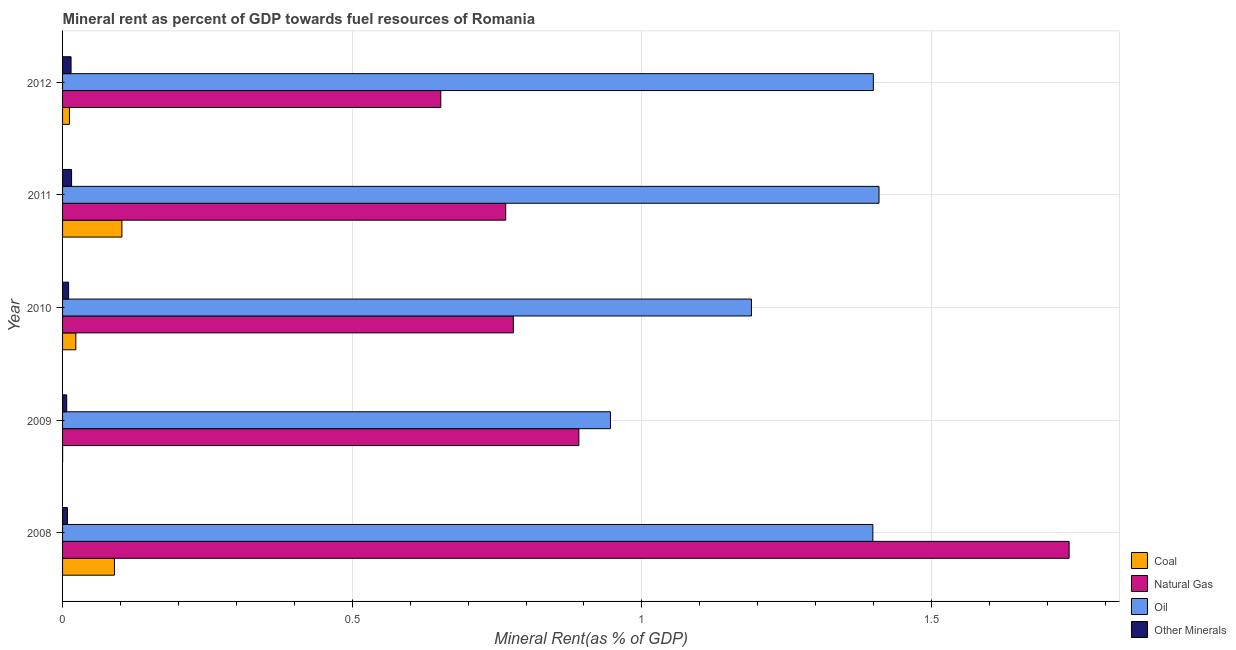Are the number of bars on each tick of the Y-axis equal?
Your response must be concise. Yes. How many bars are there on the 4th tick from the top?
Your answer should be very brief. 4. How many bars are there on the 3rd tick from the bottom?
Your response must be concise. 4. What is the  rent of other minerals in 2010?
Ensure brevity in your answer.  0.01. Across all years, what is the maximum  rent of other minerals?
Provide a succinct answer. 0.02. Across all years, what is the minimum coal rent?
Your answer should be very brief. 9.91154234092374e-5. In which year was the coal rent maximum?
Your answer should be compact. 2011. What is the total oil rent in the graph?
Keep it short and to the point. 6.34. What is the difference between the coal rent in 2011 and that in 2012?
Keep it short and to the point. 0.09. What is the difference between the natural gas rent in 2009 and the coal rent in 2012?
Your answer should be very brief. 0.88. What is the average coal rent per year?
Your answer should be very brief. 0.04. In the year 2008, what is the difference between the  rent of other minerals and oil rent?
Ensure brevity in your answer.  -1.39. In how many years, is the  rent of other minerals greater than 1.6 %?
Ensure brevity in your answer.  0. What is the ratio of the coal rent in 2010 to that in 2011?
Your answer should be very brief. 0.22. Is the coal rent in 2008 less than that in 2011?
Give a very brief answer. Yes. What does the 1st bar from the top in 2011 represents?
Make the answer very short. Other Minerals. What does the 2nd bar from the bottom in 2008 represents?
Your answer should be very brief. Natural Gas. Is it the case that in every year, the sum of the coal rent and natural gas rent is greater than the oil rent?
Your answer should be very brief. No. How many years are there in the graph?
Offer a very short reply. 5. What is the difference between two consecutive major ticks on the X-axis?
Your answer should be compact. 0.5. How are the legend labels stacked?
Your response must be concise. Vertical. What is the title of the graph?
Your answer should be compact. Mineral rent as percent of GDP towards fuel resources of Romania. What is the label or title of the X-axis?
Keep it short and to the point. Mineral Rent(as % of GDP). What is the Mineral Rent(as % of GDP) in Coal in 2008?
Offer a terse response. 0.09. What is the Mineral Rent(as % of GDP) in Natural Gas in 2008?
Provide a succinct answer. 1.74. What is the Mineral Rent(as % of GDP) in Oil in 2008?
Your answer should be very brief. 1.4. What is the Mineral Rent(as % of GDP) in Other Minerals in 2008?
Make the answer very short. 0.01. What is the Mineral Rent(as % of GDP) in Coal in 2009?
Make the answer very short. 9.91154234092374e-5. What is the Mineral Rent(as % of GDP) of Natural Gas in 2009?
Offer a terse response. 0.89. What is the Mineral Rent(as % of GDP) of Oil in 2009?
Make the answer very short. 0.95. What is the Mineral Rent(as % of GDP) in Other Minerals in 2009?
Provide a succinct answer. 0.01. What is the Mineral Rent(as % of GDP) in Coal in 2010?
Your answer should be very brief. 0.02. What is the Mineral Rent(as % of GDP) in Natural Gas in 2010?
Keep it short and to the point. 0.78. What is the Mineral Rent(as % of GDP) in Oil in 2010?
Offer a terse response. 1.19. What is the Mineral Rent(as % of GDP) in Other Minerals in 2010?
Provide a short and direct response. 0.01. What is the Mineral Rent(as % of GDP) in Coal in 2011?
Offer a very short reply. 0.1. What is the Mineral Rent(as % of GDP) in Natural Gas in 2011?
Offer a terse response. 0.76. What is the Mineral Rent(as % of GDP) in Oil in 2011?
Your response must be concise. 1.41. What is the Mineral Rent(as % of GDP) of Other Minerals in 2011?
Ensure brevity in your answer.  0.02. What is the Mineral Rent(as % of GDP) of Coal in 2012?
Provide a succinct answer. 0.01. What is the Mineral Rent(as % of GDP) of Natural Gas in 2012?
Your answer should be very brief. 0.65. What is the Mineral Rent(as % of GDP) of Oil in 2012?
Ensure brevity in your answer.  1.4. What is the Mineral Rent(as % of GDP) of Other Minerals in 2012?
Your answer should be very brief. 0.01. Across all years, what is the maximum Mineral Rent(as % of GDP) of Coal?
Your answer should be very brief. 0.1. Across all years, what is the maximum Mineral Rent(as % of GDP) of Natural Gas?
Your answer should be compact. 1.74. Across all years, what is the maximum Mineral Rent(as % of GDP) in Oil?
Offer a very short reply. 1.41. Across all years, what is the maximum Mineral Rent(as % of GDP) in Other Minerals?
Ensure brevity in your answer.  0.02. Across all years, what is the minimum Mineral Rent(as % of GDP) in Coal?
Keep it short and to the point. 9.91154234092374e-5. Across all years, what is the minimum Mineral Rent(as % of GDP) in Natural Gas?
Your response must be concise. 0.65. Across all years, what is the minimum Mineral Rent(as % of GDP) of Oil?
Keep it short and to the point. 0.95. Across all years, what is the minimum Mineral Rent(as % of GDP) of Other Minerals?
Provide a succinct answer. 0.01. What is the total Mineral Rent(as % of GDP) in Coal in the graph?
Your answer should be compact. 0.23. What is the total Mineral Rent(as % of GDP) in Natural Gas in the graph?
Keep it short and to the point. 4.82. What is the total Mineral Rent(as % of GDP) in Oil in the graph?
Your response must be concise. 6.34. What is the total Mineral Rent(as % of GDP) of Other Minerals in the graph?
Provide a short and direct response. 0.06. What is the difference between the Mineral Rent(as % of GDP) of Coal in 2008 and that in 2009?
Make the answer very short. 0.09. What is the difference between the Mineral Rent(as % of GDP) of Natural Gas in 2008 and that in 2009?
Your response must be concise. 0.85. What is the difference between the Mineral Rent(as % of GDP) of Oil in 2008 and that in 2009?
Keep it short and to the point. 0.45. What is the difference between the Mineral Rent(as % of GDP) of Other Minerals in 2008 and that in 2009?
Ensure brevity in your answer.  0. What is the difference between the Mineral Rent(as % of GDP) in Coal in 2008 and that in 2010?
Keep it short and to the point. 0.07. What is the difference between the Mineral Rent(as % of GDP) in Natural Gas in 2008 and that in 2010?
Give a very brief answer. 0.96. What is the difference between the Mineral Rent(as % of GDP) of Oil in 2008 and that in 2010?
Your response must be concise. 0.21. What is the difference between the Mineral Rent(as % of GDP) in Other Minerals in 2008 and that in 2010?
Make the answer very short. -0. What is the difference between the Mineral Rent(as % of GDP) in Coal in 2008 and that in 2011?
Keep it short and to the point. -0.01. What is the difference between the Mineral Rent(as % of GDP) of Natural Gas in 2008 and that in 2011?
Provide a succinct answer. 0.97. What is the difference between the Mineral Rent(as % of GDP) of Oil in 2008 and that in 2011?
Make the answer very short. -0.01. What is the difference between the Mineral Rent(as % of GDP) of Other Minerals in 2008 and that in 2011?
Make the answer very short. -0.01. What is the difference between the Mineral Rent(as % of GDP) in Coal in 2008 and that in 2012?
Ensure brevity in your answer.  0.08. What is the difference between the Mineral Rent(as % of GDP) of Natural Gas in 2008 and that in 2012?
Provide a succinct answer. 1.08. What is the difference between the Mineral Rent(as % of GDP) of Oil in 2008 and that in 2012?
Make the answer very short. -0. What is the difference between the Mineral Rent(as % of GDP) of Other Minerals in 2008 and that in 2012?
Ensure brevity in your answer.  -0.01. What is the difference between the Mineral Rent(as % of GDP) of Coal in 2009 and that in 2010?
Your answer should be very brief. -0.02. What is the difference between the Mineral Rent(as % of GDP) in Natural Gas in 2009 and that in 2010?
Give a very brief answer. 0.11. What is the difference between the Mineral Rent(as % of GDP) in Oil in 2009 and that in 2010?
Keep it short and to the point. -0.24. What is the difference between the Mineral Rent(as % of GDP) in Other Minerals in 2009 and that in 2010?
Offer a very short reply. -0. What is the difference between the Mineral Rent(as % of GDP) of Coal in 2009 and that in 2011?
Your answer should be compact. -0.1. What is the difference between the Mineral Rent(as % of GDP) of Natural Gas in 2009 and that in 2011?
Your response must be concise. 0.13. What is the difference between the Mineral Rent(as % of GDP) in Oil in 2009 and that in 2011?
Offer a terse response. -0.46. What is the difference between the Mineral Rent(as % of GDP) in Other Minerals in 2009 and that in 2011?
Give a very brief answer. -0.01. What is the difference between the Mineral Rent(as % of GDP) in Coal in 2009 and that in 2012?
Give a very brief answer. -0.01. What is the difference between the Mineral Rent(as % of GDP) in Natural Gas in 2009 and that in 2012?
Provide a succinct answer. 0.24. What is the difference between the Mineral Rent(as % of GDP) in Oil in 2009 and that in 2012?
Ensure brevity in your answer.  -0.45. What is the difference between the Mineral Rent(as % of GDP) in Other Minerals in 2009 and that in 2012?
Your answer should be compact. -0.01. What is the difference between the Mineral Rent(as % of GDP) of Coal in 2010 and that in 2011?
Provide a succinct answer. -0.08. What is the difference between the Mineral Rent(as % of GDP) in Natural Gas in 2010 and that in 2011?
Ensure brevity in your answer.  0.01. What is the difference between the Mineral Rent(as % of GDP) of Oil in 2010 and that in 2011?
Offer a terse response. -0.22. What is the difference between the Mineral Rent(as % of GDP) of Other Minerals in 2010 and that in 2011?
Ensure brevity in your answer.  -0.01. What is the difference between the Mineral Rent(as % of GDP) in Coal in 2010 and that in 2012?
Your answer should be very brief. 0.01. What is the difference between the Mineral Rent(as % of GDP) of Natural Gas in 2010 and that in 2012?
Ensure brevity in your answer.  0.13. What is the difference between the Mineral Rent(as % of GDP) of Oil in 2010 and that in 2012?
Your response must be concise. -0.21. What is the difference between the Mineral Rent(as % of GDP) of Other Minerals in 2010 and that in 2012?
Your response must be concise. -0. What is the difference between the Mineral Rent(as % of GDP) of Coal in 2011 and that in 2012?
Make the answer very short. 0.09. What is the difference between the Mineral Rent(as % of GDP) in Natural Gas in 2011 and that in 2012?
Give a very brief answer. 0.11. What is the difference between the Mineral Rent(as % of GDP) of Oil in 2011 and that in 2012?
Provide a short and direct response. 0.01. What is the difference between the Mineral Rent(as % of GDP) of Other Minerals in 2011 and that in 2012?
Your response must be concise. 0. What is the difference between the Mineral Rent(as % of GDP) in Coal in 2008 and the Mineral Rent(as % of GDP) in Natural Gas in 2009?
Offer a terse response. -0.8. What is the difference between the Mineral Rent(as % of GDP) in Coal in 2008 and the Mineral Rent(as % of GDP) in Oil in 2009?
Give a very brief answer. -0.86. What is the difference between the Mineral Rent(as % of GDP) of Coal in 2008 and the Mineral Rent(as % of GDP) of Other Minerals in 2009?
Keep it short and to the point. 0.08. What is the difference between the Mineral Rent(as % of GDP) in Natural Gas in 2008 and the Mineral Rent(as % of GDP) in Oil in 2009?
Your answer should be compact. 0.79. What is the difference between the Mineral Rent(as % of GDP) of Natural Gas in 2008 and the Mineral Rent(as % of GDP) of Other Minerals in 2009?
Your answer should be very brief. 1.73. What is the difference between the Mineral Rent(as % of GDP) in Oil in 2008 and the Mineral Rent(as % of GDP) in Other Minerals in 2009?
Keep it short and to the point. 1.39. What is the difference between the Mineral Rent(as % of GDP) in Coal in 2008 and the Mineral Rent(as % of GDP) in Natural Gas in 2010?
Your answer should be very brief. -0.69. What is the difference between the Mineral Rent(as % of GDP) in Coal in 2008 and the Mineral Rent(as % of GDP) in Oil in 2010?
Your response must be concise. -1.1. What is the difference between the Mineral Rent(as % of GDP) in Coal in 2008 and the Mineral Rent(as % of GDP) in Other Minerals in 2010?
Your answer should be compact. 0.08. What is the difference between the Mineral Rent(as % of GDP) in Natural Gas in 2008 and the Mineral Rent(as % of GDP) in Oil in 2010?
Your answer should be compact. 0.55. What is the difference between the Mineral Rent(as % of GDP) in Natural Gas in 2008 and the Mineral Rent(as % of GDP) in Other Minerals in 2010?
Provide a succinct answer. 1.73. What is the difference between the Mineral Rent(as % of GDP) in Oil in 2008 and the Mineral Rent(as % of GDP) in Other Minerals in 2010?
Provide a succinct answer. 1.39. What is the difference between the Mineral Rent(as % of GDP) in Coal in 2008 and the Mineral Rent(as % of GDP) in Natural Gas in 2011?
Keep it short and to the point. -0.68. What is the difference between the Mineral Rent(as % of GDP) in Coal in 2008 and the Mineral Rent(as % of GDP) in Oil in 2011?
Your answer should be compact. -1.32. What is the difference between the Mineral Rent(as % of GDP) in Coal in 2008 and the Mineral Rent(as % of GDP) in Other Minerals in 2011?
Provide a succinct answer. 0.07. What is the difference between the Mineral Rent(as % of GDP) of Natural Gas in 2008 and the Mineral Rent(as % of GDP) of Oil in 2011?
Offer a very short reply. 0.33. What is the difference between the Mineral Rent(as % of GDP) in Natural Gas in 2008 and the Mineral Rent(as % of GDP) in Other Minerals in 2011?
Give a very brief answer. 1.72. What is the difference between the Mineral Rent(as % of GDP) in Oil in 2008 and the Mineral Rent(as % of GDP) in Other Minerals in 2011?
Offer a very short reply. 1.38. What is the difference between the Mineral Rent(as % of GDP) of Coal in 2008 and the Mineral Rent(as % of GDP) of Natural Gas in 2012?
Provide a short and direct response. -0.56. What is the difference between the Mineral Rent(as % of GDP) of Coal in 2008 and the Mineral Rent(as % of GDP) of Oil in 2012?
Your response must be concise. -1.31. What is the difference between the Mineral Rent(as % of GDP) in Coal in 2008 and the Mineral Rent(as % of GDP) in Other Minerals in 2012?
Your answer should be very brief. 0.07. What is the difference between the Mineral Rent(as % of GDP) in Natural Gas in 2008 and the Mineral Rent(as % of GDP) in Oil in 2012?
Give a very brief answer. 0.34. What is the difference between the Mineral Rent(as % of GDP) in Natural Gas in 2008 and the Mineral Rent(as % of GDP) in Other Minerals in 2012?
Provide a succinct answer. 1.72. What is the difference between the Mineral Rent(as % of GDP) of Oil in 2008 and the Mineral Rent(as % of GDP) of Other Minerals in 2012?
Provide a short and direct response. 1.38. What is the difference between the Mineral Rent(as % of GDP) in Coal in 2009 and the Mineral Rent(as % of GDP) in Natural Gas in 2010?
Keep it short and to the point. -0.78. What is the difference between the Mineral Rent(as % of GDP) in Coal in 2009 and the Mineral Rent(as % of GDP) in Oil in 2010?
Your answer should be very brief. -1.19. What is the difference between the Mineral Rent(as % of GDP) of Coal in 2009 and the Mineral Rent(as % of GDP) of Other Minerals in 2010?
Make the answer very short. -0.01. What is the difference between the Mineral Rent(as % of GDP) of Natural Gas in 2009 and the Mineral Rent(as % of GDP) of Oil in 2010?
Give a very brief answer. -0.3. What is the difference between the Mineral Rent(as % of GDP) in Natural Gas in 2009 and the Mineral Rent(as % of GDP) in Other Minerals in 2010?
Offer a terse response. 0.88. What is the difference between the Mineral Rent(as % of GDP) in Oil in 2009 and the Mineral Rent(as % of GDP) in Other Minerals in 2010?
Give a very brief answer. 0.94. What is the difference between the Mineral Rent(as % of GDP) in Coal in 2009 and the Mineral Rent(as % of GDP) in Natural Gas in 2011?
Offer a terse response. -0.76. What is the difference between the Mineral Rent(as % of GDP) of Coal in 2009 and the Mineral Rent(as % of GDP) of Oil in 2011?
Your answer should be very brief. -1.41. What is the difference between the Mineral Rent(as % of GDP) in Coal in 2009 and the Mineral Rent(as % of GDP) in Other Minerals in 2011?
Your response must be concise. -0.02. What is the difference between the Mineral Rent(as % of GDP) in Natural Gas in 2009 and the Mineral Rent(as % of GDP) in Oil in 2011?
Your answer should be very brief. -0.52. What is the difference between the Mineral Rent(as % of GDP) of Natural Gas in 2009 and the Mineral Rent(as % of GDP) of Other Minerals in 2011?
Your response must be concise. 0.88. What is the difference between the Mineral Rent(as % of GDP) of Oil in 2009 and the Mineral Rent(as % of GDP) of Other Minerals in 2011?
Your answer should be very brief. 0.93. What is the difference between the Mineral Rent(as % of GDP) in Coal in 2009 and the Mineral Rent(as % of GDP) in Natural Gas in 2012?
Offer a very short reply. -0.65. What is the difference between the Mineral Rent(as % of GDP) in Coal in 2009 and the Mineral Rent(as % of GDP) in Oil in 2012?
Offer a terse response. -1.4. What is the difference between the Mineral Rent(as % of GDP) of Coal in 2009 and the Mineral Rent(as % of GDP) of Other Minerals in 2012?
Offer a very short reply. -0.01. What is the difference between the Mineral Rent(as % of GDP) of Natural Gas in 2009 and the Mineral Rent(as % of GDP) of Oil in 2012?
Your answer should be compact. -0.51. What is the difference between the Mineral Rent(as % of GDP) of Natural Gas in 2009 and the Mineral Rent(as % of GDP) of Other Minerals in 2012?
Offer a very short reply. 0.88. What is the difference between the Mineral Rent(as % of GDP) of Coal in 2010 and the Mineral Rent(as % of GDP) of Natural Gas in 2011?
Give a very brief answer. -0.74. What is the difference between the Mineral Rent(as % of GDP) of Coal in 2010 and the Mineral Rent(as % of GDP) of Oil in 2011?
Provide a succinct answer. -1.39. What is the difference between the Mineral Rent(as % of GDP) in Coal in 2010 and the Mineral Rent(as % of GDP) in Other Minerals in 2011?
Offer a terse response. 0.01. What is the difference between the Mineral Rent(as % of GDP) in Natural Gas in 2010 and the Mineral Rent(as % of GDP) in Oil in 2011?
Your answer should be compact. -0.63. What is the difference between the Mineral Rent(as % of GDP) of Natural Gas in 2010 and the Mineral Rent(as % of GDP) of Other Minerals in 2011?
Make the answer very short. 0.76. What is the difference between the Mineral Rent(as % of GDP) in Oil in 2010 and the Mineral Rent(as % of GDP) in Other Minerals in 2011?
Provide a succinct answer. 1.17. What is the difference between the Mineral Rent(as % of GDP) of Coal in 2010 and the Mineral Rent(as % of GDP) of Natural Gas in 2012?
Keep it short and to the point. -0.63. What is the difference between the Mineral Rent(as % of GDP) of Coal in 2010 and the Mineral Rent(as % of GDP) of Oil in 2012?
Your answer should be compact. -1.38. What is the difference between the Mineral Rent(as % of GDP) of Coal in 2010 and the Mineral Rent(as % of GDP) of Other Minerals in 2012?
Make the answer very short. 0.01. What is the difference between the Mineral Rent(as % of GDP) in Natural Gas in 2010 and the Mineral Rent(as % of GDP) in Oil in 2012?
Give a very brief answer. -0.62. What is the difference between the Mineral Rent(as % of GDP) in Natural Gas in 2010 and the Mineral Rent(as % of GDP) in Other Minerals in 2012?
Offer a very short reply. 0.76. What is the difference between the Mineral Rent(as % of GDP) of Oil in 2010 and the Mineral Rent(as % of GDP) of Other Minerals in 2012?
Provide a short and direct response. 1.17. What is the difference between the Mineral Rent(as % of GDP) in Coal in 2011 and the Mineral Rent(as % of GDP) in Natural Gas in 2012?
Give a very brief answer. -0.55. What is the difference between the Mineral Rent(as % of GDP) in Coal in 2011 and the Mineral Rent(as % of GDP) in Oil in 2012?
Make the answer very short. -1.3. What is the difference between the Mineral Rent(as % of GDP) of Coal in 2011 and the Mineral Rent(as % of GDP) of Other Minerals in 2012?
Your answer should be compact. 0.09. What is the difference between the Mineral Rent(as % of GDP) of Natural Gas in 2011 and the Mineral Rent(as % of GDP) of Oil in 2012?
Your answer should be compact. -0.63. What is the difference between the Mineral Rent(as % of GDP) of Natural Gas in 2011 and the Mineral Rent(as % of GDP) of Other Minerals in 2012?
Give a very brief answer. 0.75. What is the difference between the Mineral Rent(as % of GDP) in Oil in 2011 and the Mineral Rent(as % of GDP) in Other Minerals in 2012?
Keep it short and to the point. 1.39. What is the average Mineral Rent(as % of GDP) of Coal per year?
Your answer should be compact. 0.05. What is the average Mineral Rent(as % of GDP) of Natural Gas per year?
Keep it short and to the point. 0.96. What is the average Mineral Rent(as % of GDP) of Oil per year?
Offer a terse response. 1.27. What is the average Mineral Rent(as % of GDP) of Other Minerals per year?
Provide a short and direct response. 0.01. In the year 2008, what is the difference between the Mineral Rent(as % of GDP) of Coal and Mineral Rent(as % of GDP) of Natural Gas?
Provide a succinct answer. -1.65. In the year 2008, what is the difference between the Mineral Rent(as % of GDP) in Coal and Mineral Rent(as % of GDP) in Oil?
Ensure brevity in your answer.  -1.31. In the year 2008, what is the difference between the Mineral Rent(as % of GDP) of Coal and Mineral Rent(as % of GDP) of Other Minerals?
Provide a short and direct response. 0.08. In the year 2008, what is the difference between the Mineral Rent(as % of GDP) of Natural Gas and Mineral Rent(as % of GDP) of Oil?
Ensure brevity in your answer.  0.34. In the year 2008, what is the difference between the Mineral Rent(as % of GDP) of Natural Gas and Mineral Rent(as % of GDP) of Other Minerals?
Provide a succinct answer. 1.73. In the year 2008, what is the difference between the Mineral Rent(as % of GDP) of Oil and Mineral Rent(as % of GDP) of Other Minerals?
Make the answer very short. 1.39. In the year 2009, what is the difference between the Mineral Rent(as % of GDP) of Coal and Mineral Rent(as % of GDP) of Natural Gas?
Give a very brief answer. -0.89. In the year 2009, what is the difference between the Mineral Rent(as % of GDP) of Coal and Mineral Rent(as % of GDP) of Oil?
Provide a succinct answer. -0.95. In the year 2009, what is the difference between the Mineral Rent(as % of GDP) in Coal and Mineral Rent(as % of GDP) in Other Minerals?
Ensure brevity in your answer.  -0.01. In the year 2009, what is the difference between the Mineral Rent(as % of GDP) in Natural Gas and Mineral Rent(as % of GDP) in Oil?
Provide a succinct answer. -0.05. In the year 2009, what is the difference between the Mineral Rent(as % of GDP) in Natural Gas and Mineral Rent(as % of GDP) in Other Minerals?
Your response must be concise. 0.88. In the year 2009, what is the difference between the Mineral Rent(as % of GDP) of Oil and Mineral Rent(as % of GDP) of Other Minerals?
Ensure brevity in your answer.  0.94. In the year 2010, what is the difference between the Mineral Rent(as % of GDP) of Coal and Mineral Rent(as % of GDP) of Natural Gas?
Your response must be concise. -0.76. In the year 2010, what is the difference between the Mineral Rent(as % of GDP) in Coal and Mineral Rent(as % of GDP) in Oil?
Give a very brief answer. -1.17. In the year 2010, what is the difference between the Mineral Rent(as % of GDP) in Coal and Mineral Rent(as % of GDP) in Other Minerals?
Keep it short and to the point. 0.01. In the year 2010, what is the difference between the Mineral Rent(as % of GDP) in Natural Gas and Mineral Rent(as % of GDP) in Oil?
Make the answer very short. -0.41. In the year 2010, what is the difference between the Mineral Rent(as % of GDP) in Natural Gas and Mineral Rent(as % of GDP) in Other Minerals?
Make the answer very short. 0.77. In the year 2010, what is the difference between the Mineral Rent(as % of GDP) in Oil and Mineral Rent(as % of GDP) in Other Minerals?
Your answer should be very brief. 1.18. In the year 2011, what is the difference between the Mineral Rent(as % of GDP) in Coal and Mineral Rent(as % of GDP) in Natural Gas?
Give a very brief answer. -0.66. In the year 2011, what is the difference between the Mineral Rent(as % of GDP) in Coal and Mineral Rent(as % of GDP) in Oil?
Ensure brevity in your answer.  -1.31. In the year 2011, what is the difference between the Mineral Rent(as % of GDP) in Coal and Mineral Rent(as % of GDP) in Other Minerals?
Your answer should be very brief. 0.09. In the year 2011, what is the difference between the Mineral Rent(as % of GDP) in Natural Gas and Mineral Rent(as % of GDP) in Oil?
Keep it short and to the point. -0.64. In the year 2011, what is the difference between the Mineral Rent(as % of GDP) in Natural Gas and Mineral Rent(as % of GDP) in Other Minerals?
Make the answer very short. 0.75. In the year 2011, what is the difference between the Mineral Rent(as % of GDP) of Oil and Mineral Rent(as % of GDP) of Other Minerals?
Provide a succinct answer. 1.39. In the year 2012, what is the difference between the Mineral Rent(as % of GDP) in Coal and Mineral Rent(as % of GDP) in Natural Gas?
Provide a short and direct response. -0.64. In the year 2012, what is the difference between the Mineral Rent(as % of GDP) in Coal and Mineral Rent(as % of GDP) in Oil?
Keep it short and to the point. -1.39. In the year 2012, what is the difference between the Mineral Rent(as % of GDP) of Coal and Mineral Rent(as % of GDP) of Other Minerals?
Provide a succinct answer. -0. In the year 2012, what is the difference between the Mineral Rent(as % of GDP) in Natural Gas and Mineral Rent(as % of GDP) in Oil?
Your response must be concise. -0.75. In the year 2012, what is the difference between the Mineral Rent(as % of GDP) in Natural Gas and Mineral Rent(as % of GDP) in Other Minerals?
Ensure brevity in your answer.  0.64. In the year 2012, what is the difference between the Mineral Rent(as % of GDP) of Oil and Mineral Rent(as % of GDP) of Other Minerals?
Your answer should be very brief. 1.38. What is the ratio of the Mineral Rent(as % of GDP) in Coal in 2008 to that in 2009?
Your response must be concise. 903.21. What is the ratio of the Mineral Rent(as % of GDP) of Natural Gas in 2008 to that in 2009?
Offer a terse response. 1.95. What is the ratio of the Mineral Rent(as % of GDP) in Oil in 2008 to that in 2009?
Your response must be concise. 1.48. What is the ratio of the Mineral Rent(as % of GDP) of Other Minerals in 2008 to that in 2009?
Provide a short and direct response. 1.17. What is the ratio of the Mineral Rent(as % of GDP) in Coal in 2008 to that in 2010?
Ensure brevity in your answer.  3.91. What is the ratio of the Mineral Rent(as % of GDP) in Natural Gas in 2008 to that in 2010?
Ensure brevity in your answer.  2.23. What is the ratio of the Mineral Rent(as % of GDP) of Oil in 2008 to that in 2010?
Your response must be concise. 1.18. What is the ratio of the Mineral Rent(as % of GDP) in Other Minerals in 2008 to that in 2010?
Keep it short and to the point. 0.81. What is the ratio of the Mineral Rent(as % of GDP) of Coal in 2008 to that in 2011?
Your answer should be compact. 0.87. What is the ratio of the Mineral Rent(as % of GDP) of Natural Gas in 2008 to that in 2011?
Ensure brevity in your answer.  2.27. What is the ratio of the Mineral Rent(as % of GDP) of Oil in 2008 to that in 2011?
Keep it short and to the point. 0.99. What is the ratio of the Mineral Rent(as % of GDP) of Other Minerals in 2008 to that in 2011?
Offer a very short reply. 0.54. What is the ratio of the Mineral Rent(as % of GDP) of Coal in 2008 to that in 2012?
Ensure brevity in your answer.  7.51. What is the ratio of the Mineral Rent(as % of GDP) of Natural Gas in 2008 to that in 2012?
Provide a succinct answer. 2.66. What is the ratio of the Mineral Rent(as % of GDP) in Oil in 2008 to that in 2012?
Give a very brief answer. 1. What is the ratio of the Mineral Rent(as % of GDP) in Other Minerals in 2008 to that in 2012?
Make the answer very short. 0.57. What is the ratio of the Mineral Rent(as % of GDP) in Coal in 2009 to that in 2010?
Provide a succinct answer. 0. What is the ratio of the Mineral Rent(as % of GDP) in Natural Gas in 2009 to that in 2010?
Give a very brief answer. 1.15. What is the ratio of the Mineral Rent(as % of GDP) in Oil in 2009 to that in 2010?
Offer a terse response. 0.8. What is the ratio of the Mineral Rent(as % of GDP) in Other Minerals in 2009 to that in 2010?
Your answer should be very brief. 0.69. What is the ratio of the Mineral Rent(as % of GDP) in Natural Gas in 2009 to that in 2011?
Your answer should be very brief. 1.17. What is the ratio of the Mineral Rent(as % of GDP) of Oil in 2009 to that in 2011?
Your answer should be compact. 0.67. What is the ratio of the Mineral Rent(as % of GDP) of Other Minerals in 2009 to that in 2011?
Offer a very short reply. 0.46. What is the ratio of the Mineral Rent(as % of GDP) in Coal in 2009 to that in 2012?
Provide a succinct answer. 0.01. What is the ratio of the Mineral Rent(as % of GDP) in Natural Gas in 2009 to that in 2012?
Your answer should be very brief. 1.36. What is the ratio of the Mineral Rent(as % of GDP) in Oil in 2009 to that in 2012?
Provide a short and direct response. 0.68. What is the ratio of the Mineral Rent(as % of GDP) of Other Minerals in 2009 to that in 2012?
Keep it short and to the point. 0.49. What is the ratio of the Mineral Rent(as % of GDP) in Coal in 2010 to that in 2011?
Make the answer very short. 0.22. What is the ratio of the Mineral Rent(as % of GDP) in Natural Gas in 2010 to that in 2011?
Make the answer very short. 1.02. What is the ratio of the Mineral Rent(as % of GDP) in Oil in 2010 to that in 2011?
Offer a very short reply. 0.84. What is the ratio of the Mineral Rent(as % of GDP) in Other Minerals in 2010 to that in 2011?
Make the answer very short. 0.67. What is the ratio of the Mineral Rent(as % of GDP) of Coal in 2010 to that in 2012?
Make the answer very short. 1.92. What is the ratio of the Mineral Rent(as % of GDP) in Natural Gas in 2010 to that in 2012?
Provide a succinct answer. 1.19. What is the ratio of the Mineral Rent(as % of GDP) in Oil in 2010 to that in 2012?
Keep it short and to the point. 0.85. What is the ratio of the Mineral Rent(as % of GDP) in Other Minerals in 2010 to that in 2012?
Your answer should be very brief. 0.71. What is the ratio of the Mineral Rent(as % of GDP) in Coal in 2011 to that in 2012?
Your answer should be very brief. 8.6. What is the ratio of the Mineral Rent(as % of GDP) of Natural Gas in 2011 to that in 2012?
Provide a short and direct response. 1.17. What is the ratio of the Mineral Rent(as % of GDP) of Other Minerals in 2011 to that in 2012?
Provide a succinct answer. 1.06. What is the difference between the highest and the second highest Mineral Rent(as % of GDP) in Coal?
Provide a succinct answer. 0.01. What is the difference between the highest and the second highest Mineral Rent(as % of GDP) of Natural Gas?
Keep it short and to the point. 0.85. What is the difference between the highest and the second highest Mineral Rent(as % of GDP) in Oil?
Keep it short and to the point. 0.01. What is the difference between the highest and the second highest Mineral Rent(as % of GDP) in Other Minerals?
Provide a succinct answer. 0. What is the difference between the highest and the lowest Mineral Rent(as % of GDP) in Coal?
Make the answer very short. 0.1. What is the difference between the highest and the lowest Mineral Rent(as % of GDP) of Natural Gas?
Your answer should be very brief. 1.08. What is the difference between the highest and the lowest Mineral Rent(as % of GDP) in Oil?
Offer a terse response. 0.46. What is the difference between the highest and the lowest Mineral Rent(as % of GDP) in Other Minerals?
Provide a succinct answer. 0.01. 